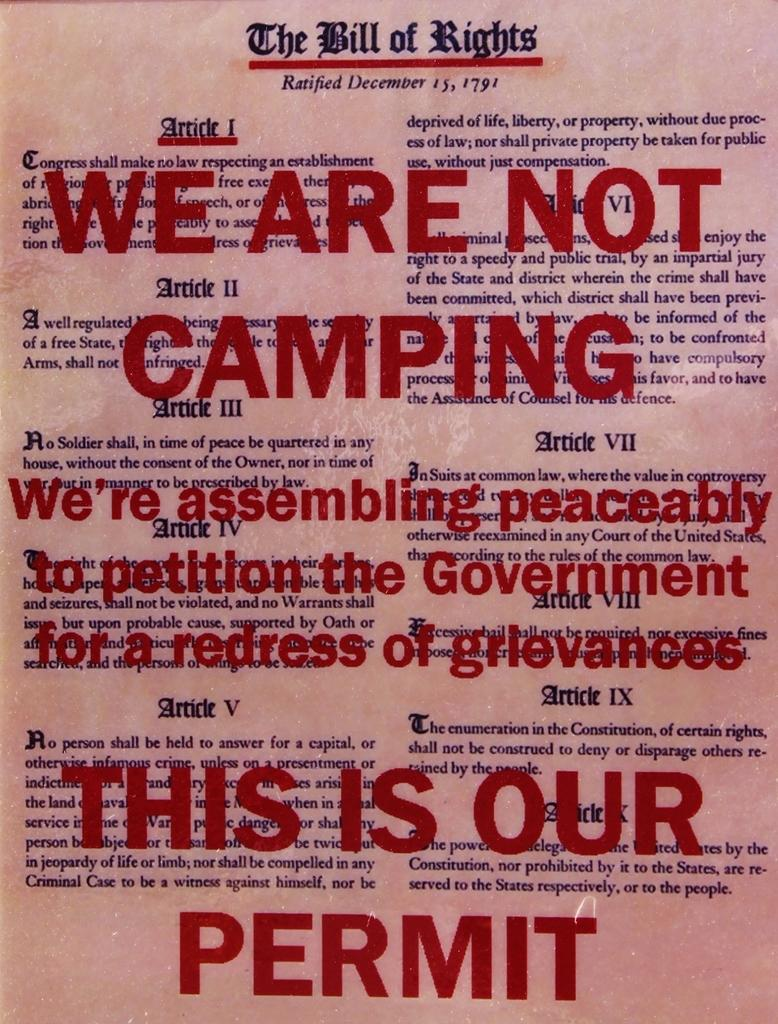<image>
Summarize the visual content of the image. A copy of the bill of rights has red letters written over it. 